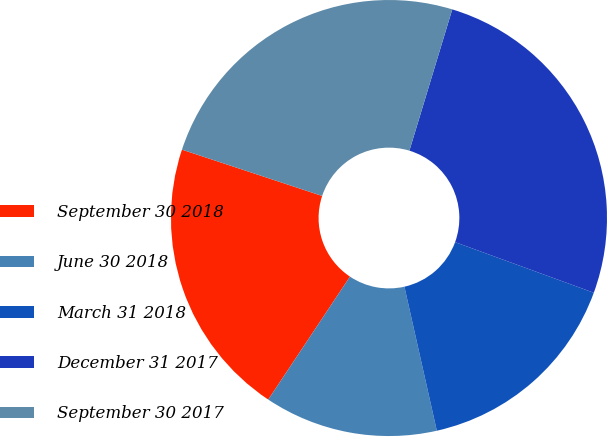Convert chart. <chart><loc_0><loc_0><loc_500><loc_500><pie_chart><fcel>September 30 2018<fcel>June 30 2018<fcel>March 31 2018<fcel>December 31 2017<fcel>September 30 2017<nl><fcel>20.74%<fcel>12.86%<fcel>15.91%<fcel>25.88%<fcel>24.61%<nl></chart> 